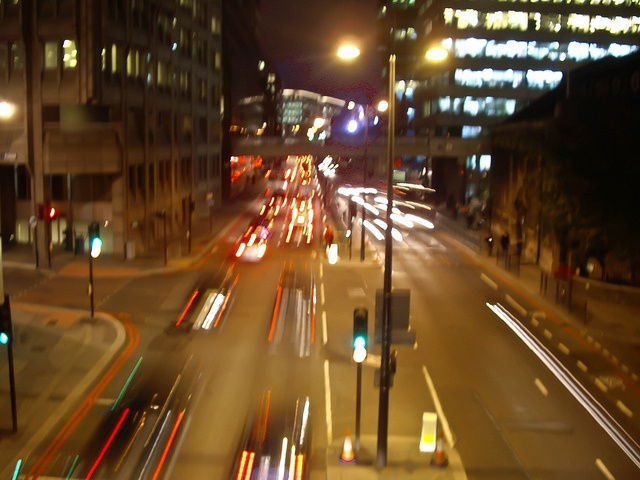Describe the objects in this image and their specific colors. I can see car in olive, ivory, brown, khaki, and tan tones, traffic light in olive, white, black, and maroon tones, traffic light in olive, black, white, and maroon tones, car in olive, brown, tan, and khaki tones, and traffic light in olive, black, white, and cyan tones in this image. 